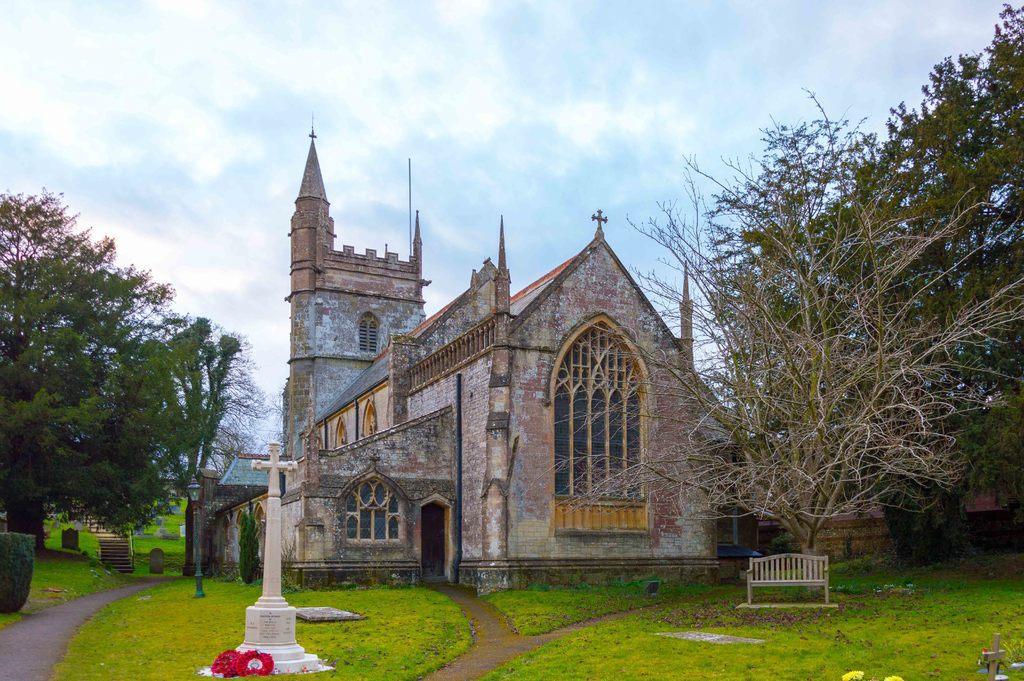How would you summarize this image in a sentence or two? In this picture I can see a building, there are stars, there are flowers, there is a bench, grass, there are trees, and in the background there is the sky. 